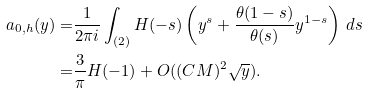Convert formula to latex. <formula><loc_0><loc_0><loc_500><loc_500>a _ { 0 , h } ( y ) = & \frac { 1 } { 2 \pi i } \int _ { ( 2 ) } H ( - s ) \left ( y ^ { s } + \frac { \theta ( 1 - s ) } { \theta ( s ) } y ^ { 1 - s } \right ) \, d s \\ = & \frac { 3 } { \pi } H ( - 1 ) + O ( ( C M ) ^ { 2 } \sqrt { y } ) .</formula> 